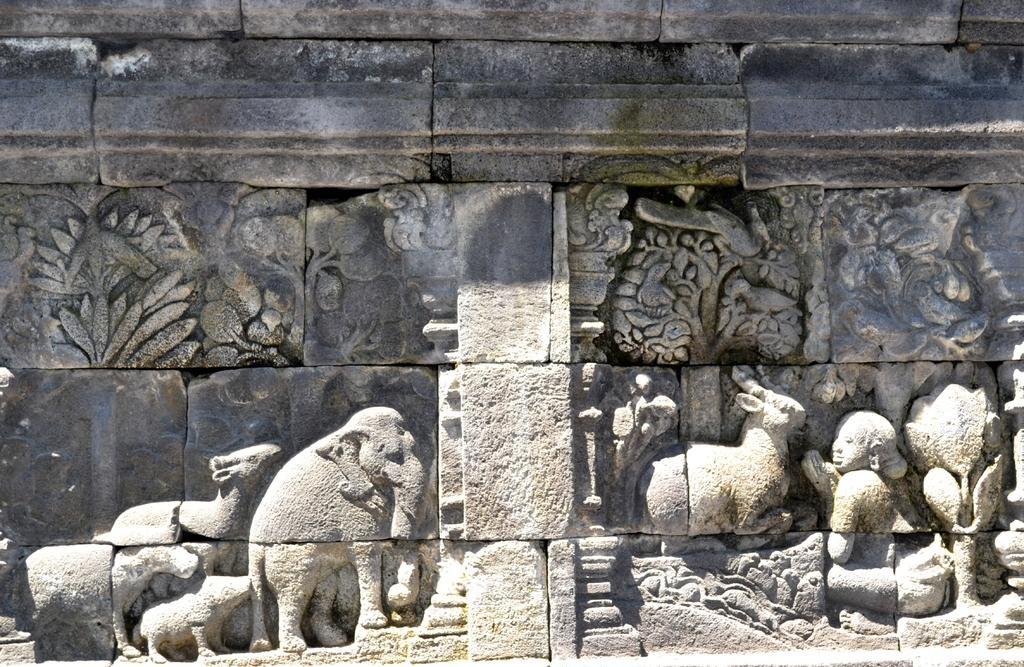How would you summarize this image in a sentence or two? In this image I can see few sculptures of animals and persons on a wall. 